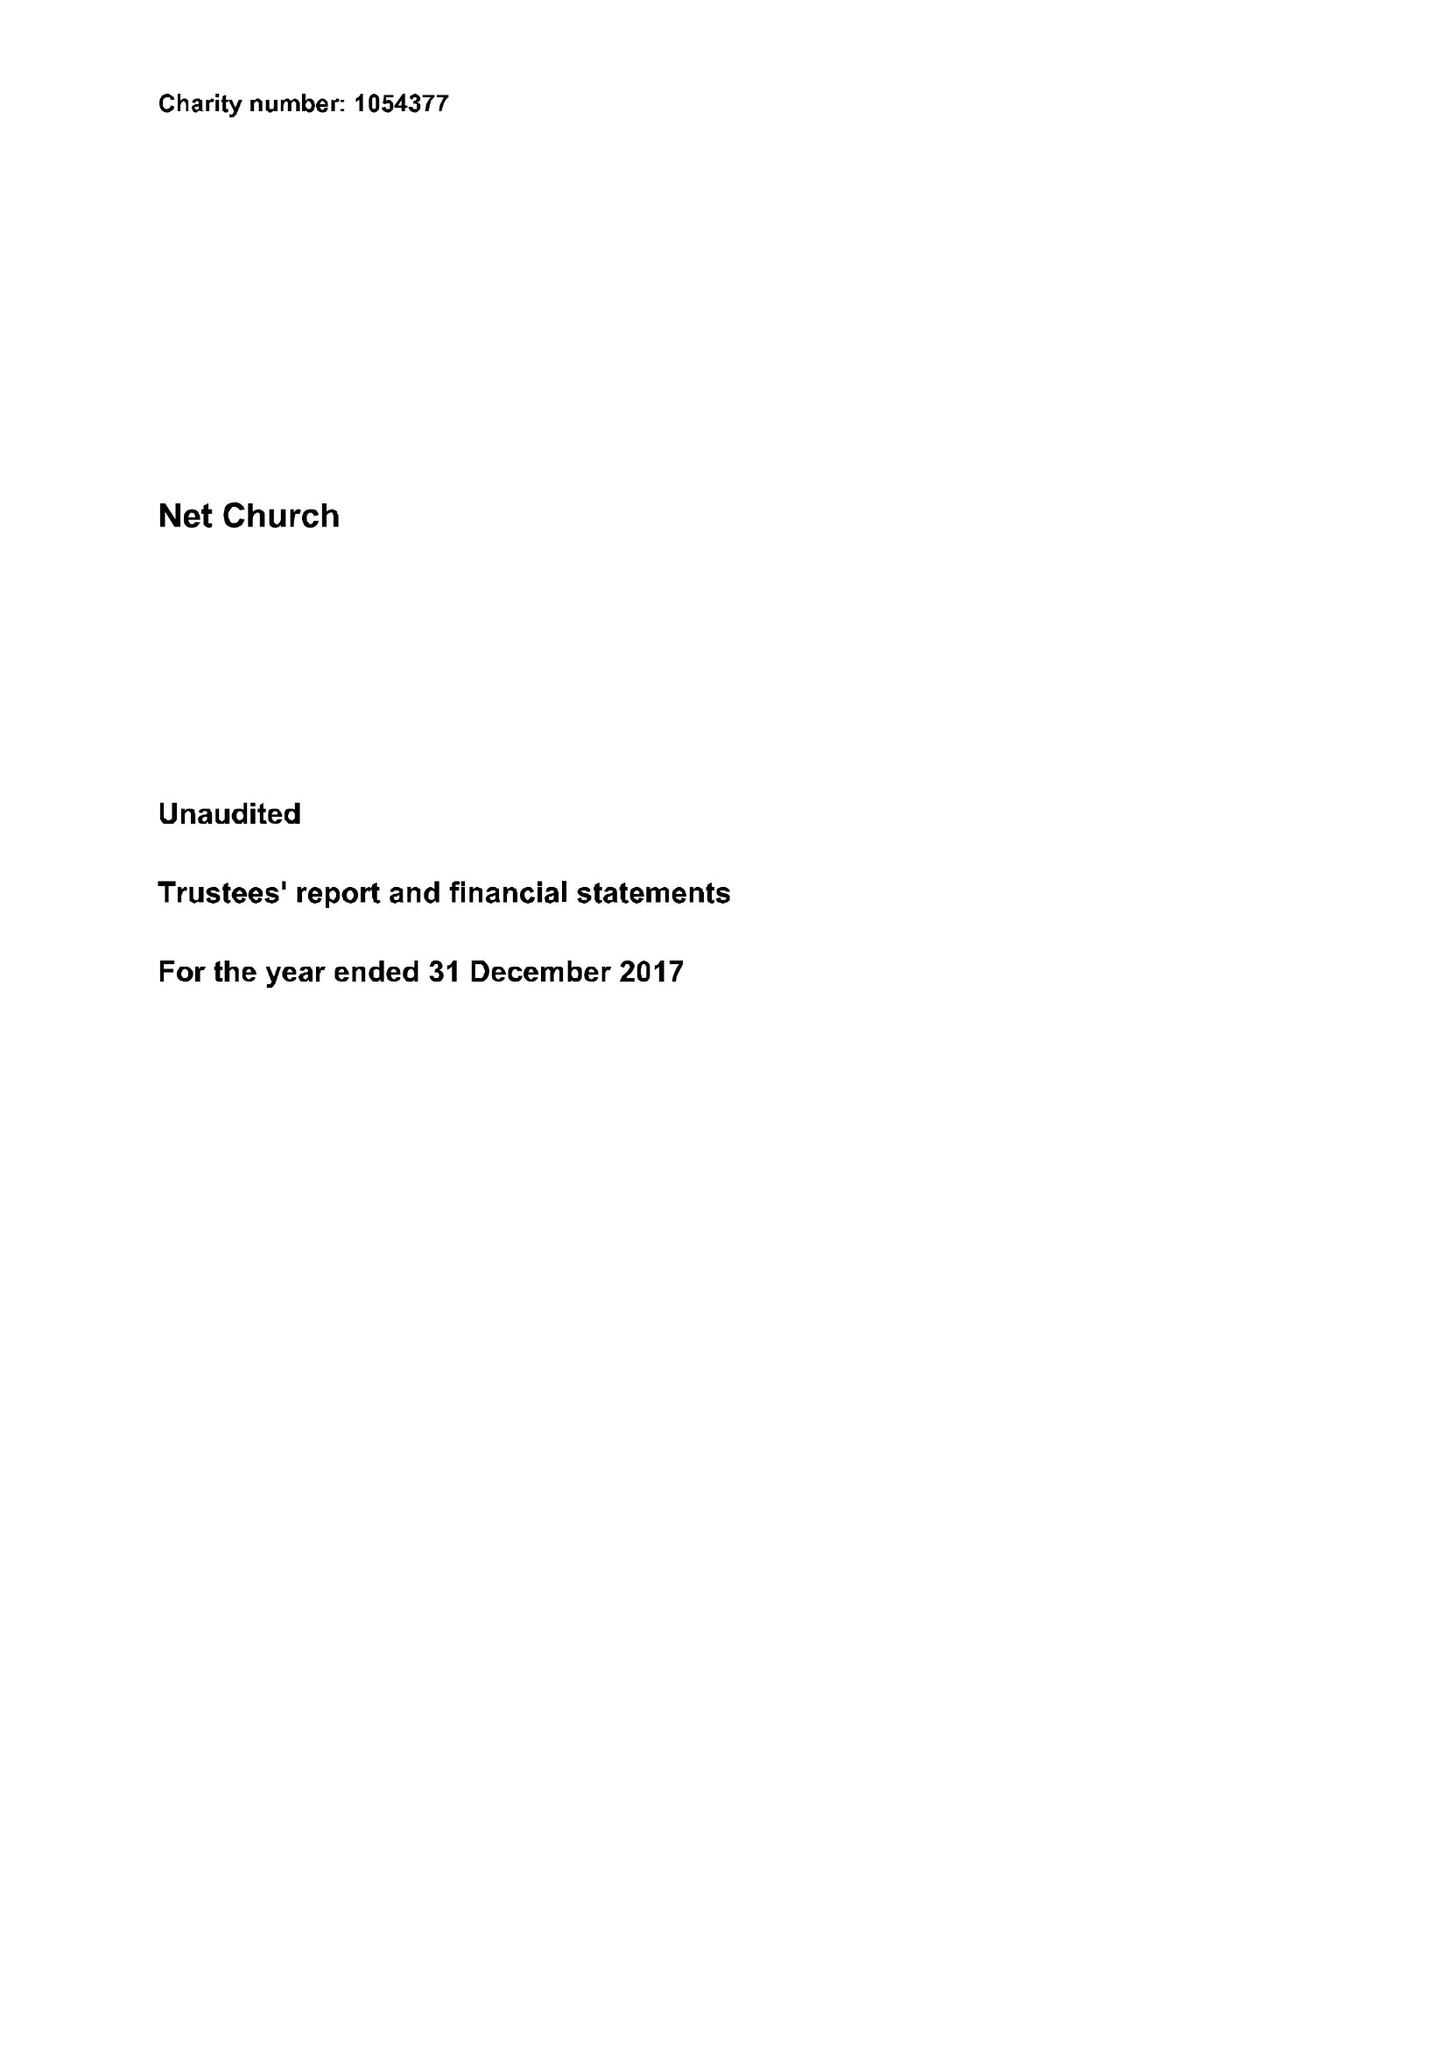What is the value for the charity_name?
Answer the question using a single word or phrase. Net Church 